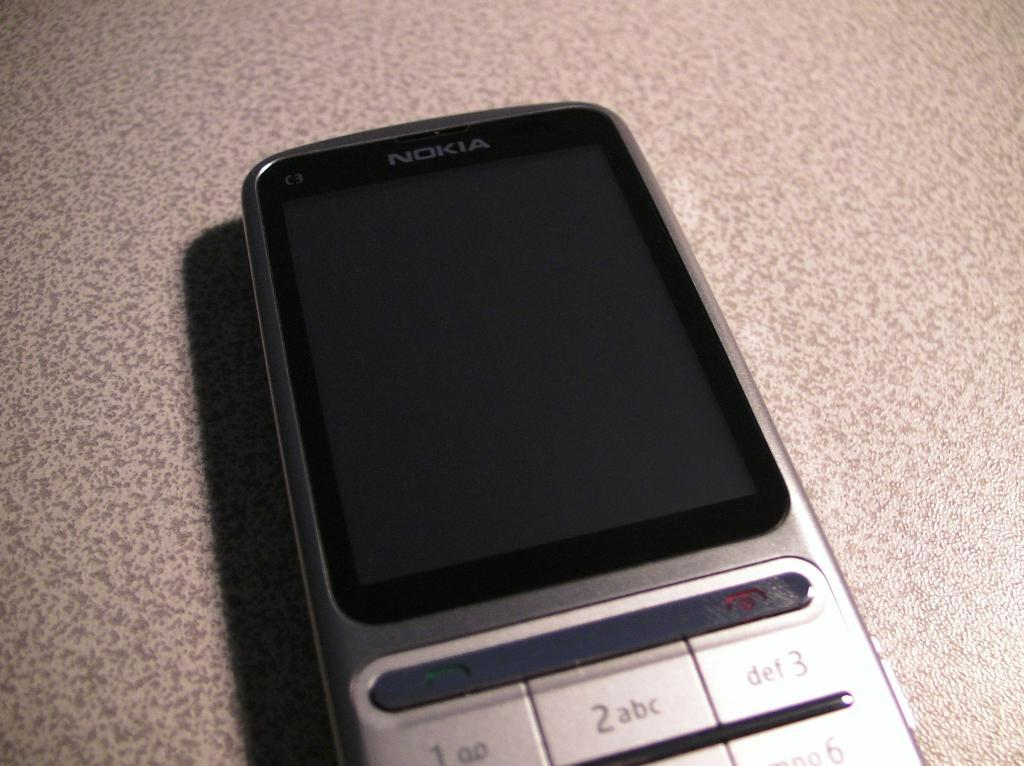<image>
Write a terse but informative summary of the picture. The unpowered screen of a nokia branded phone is sitting on a gray surface. 